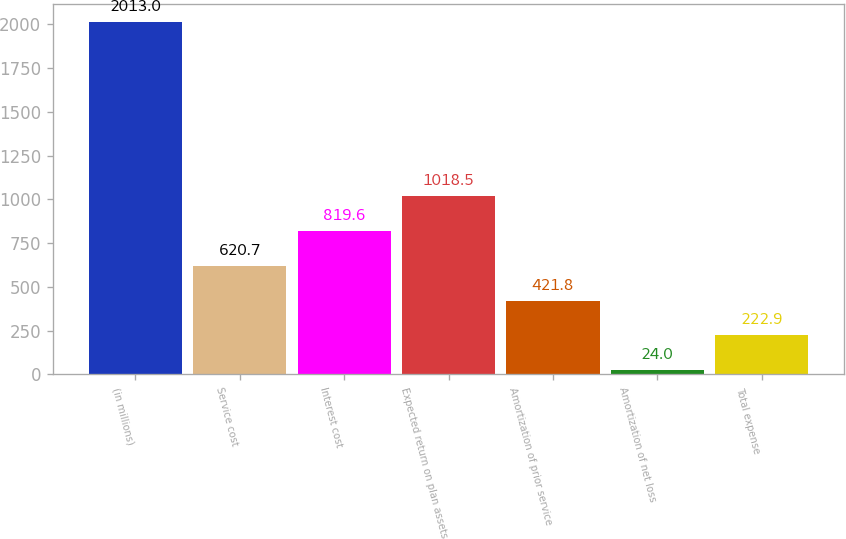Convert chart to OTSL. <chart><loc_0><loc_0><loc_500><loc_500><bar_chart><fcel>(in millions)<fcel>Service cost<fcel>Interest cost<fcel>Expected return on plan assets<fcel>Amortization of prior service<fcel>Amortization of net loss<fcel>Total expense<nl><fcel>2013<fcel>620.7<fcel>819.6<fcel>1018.5<fcel>421.8<fcel>24<fcel>222.9<nl></chart> 